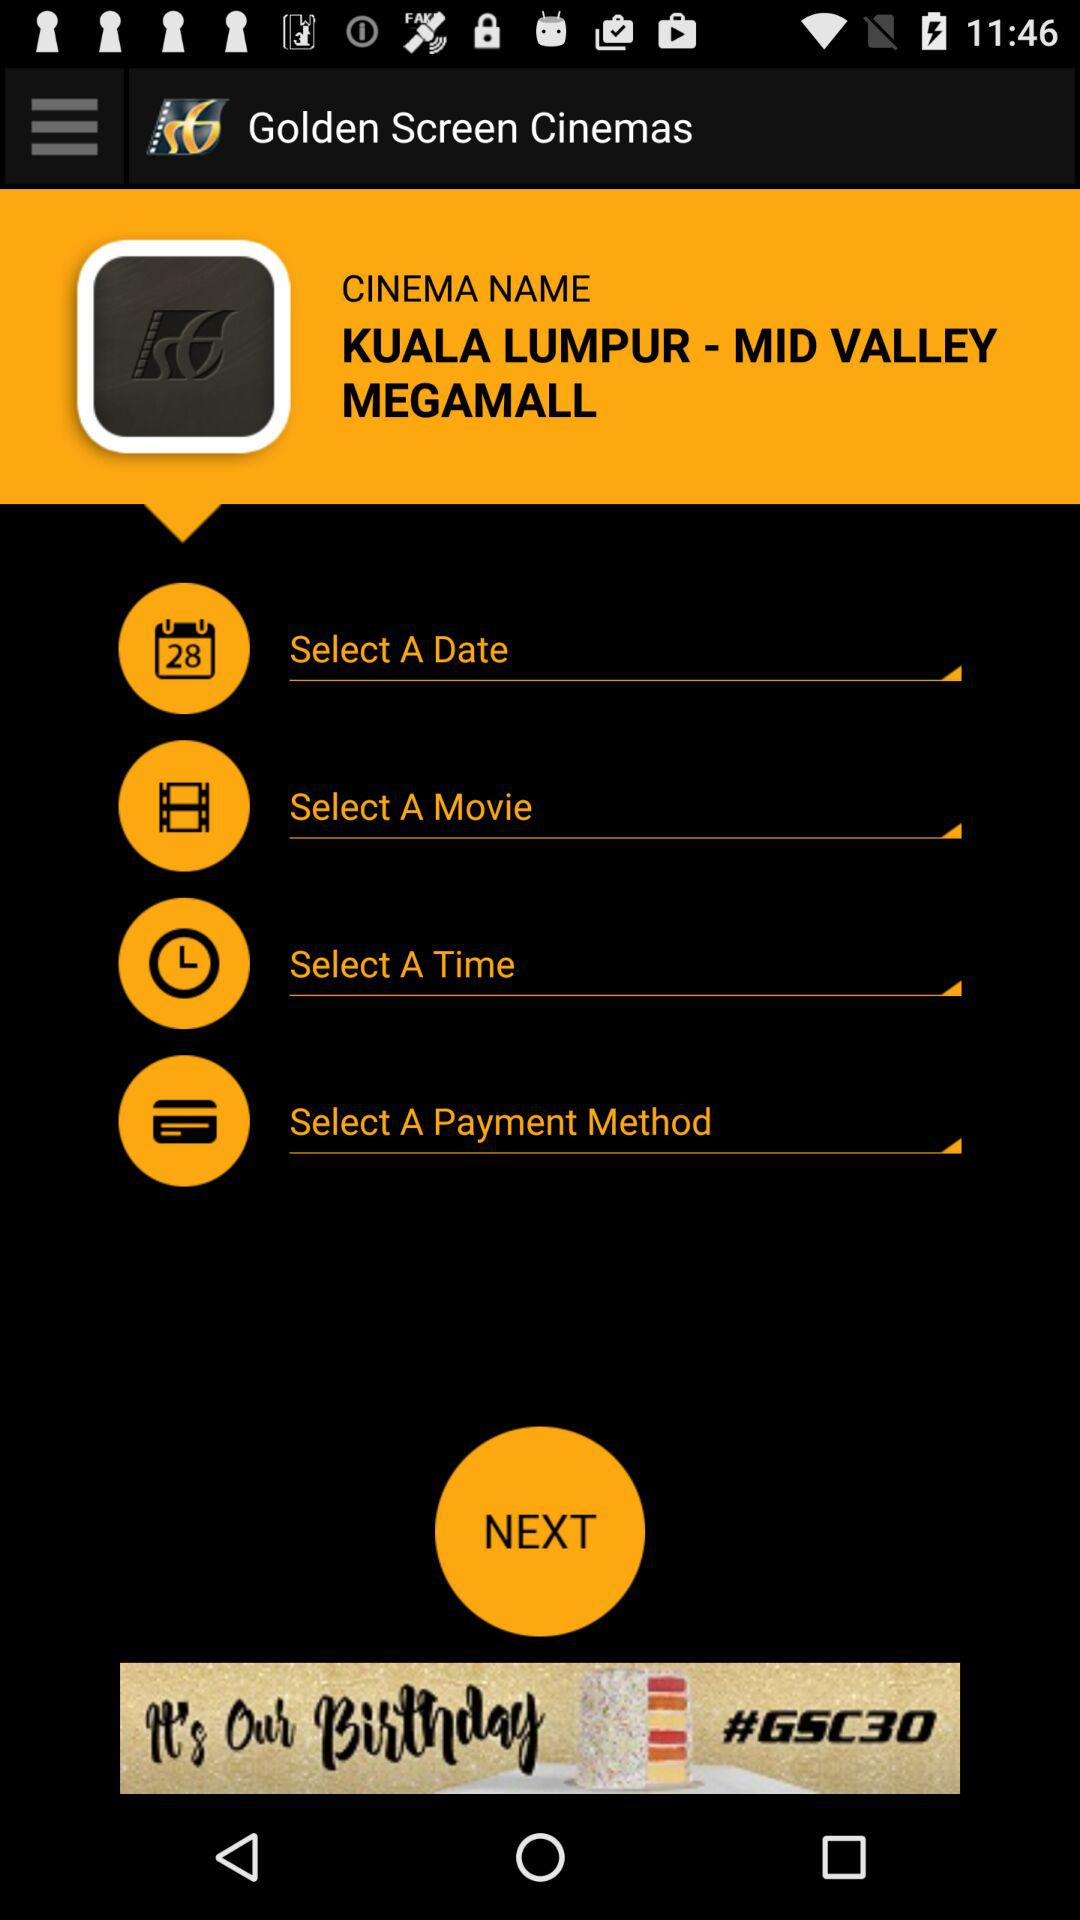What is the name of the application? The name of the application is "Golden Screen Cinemas". 